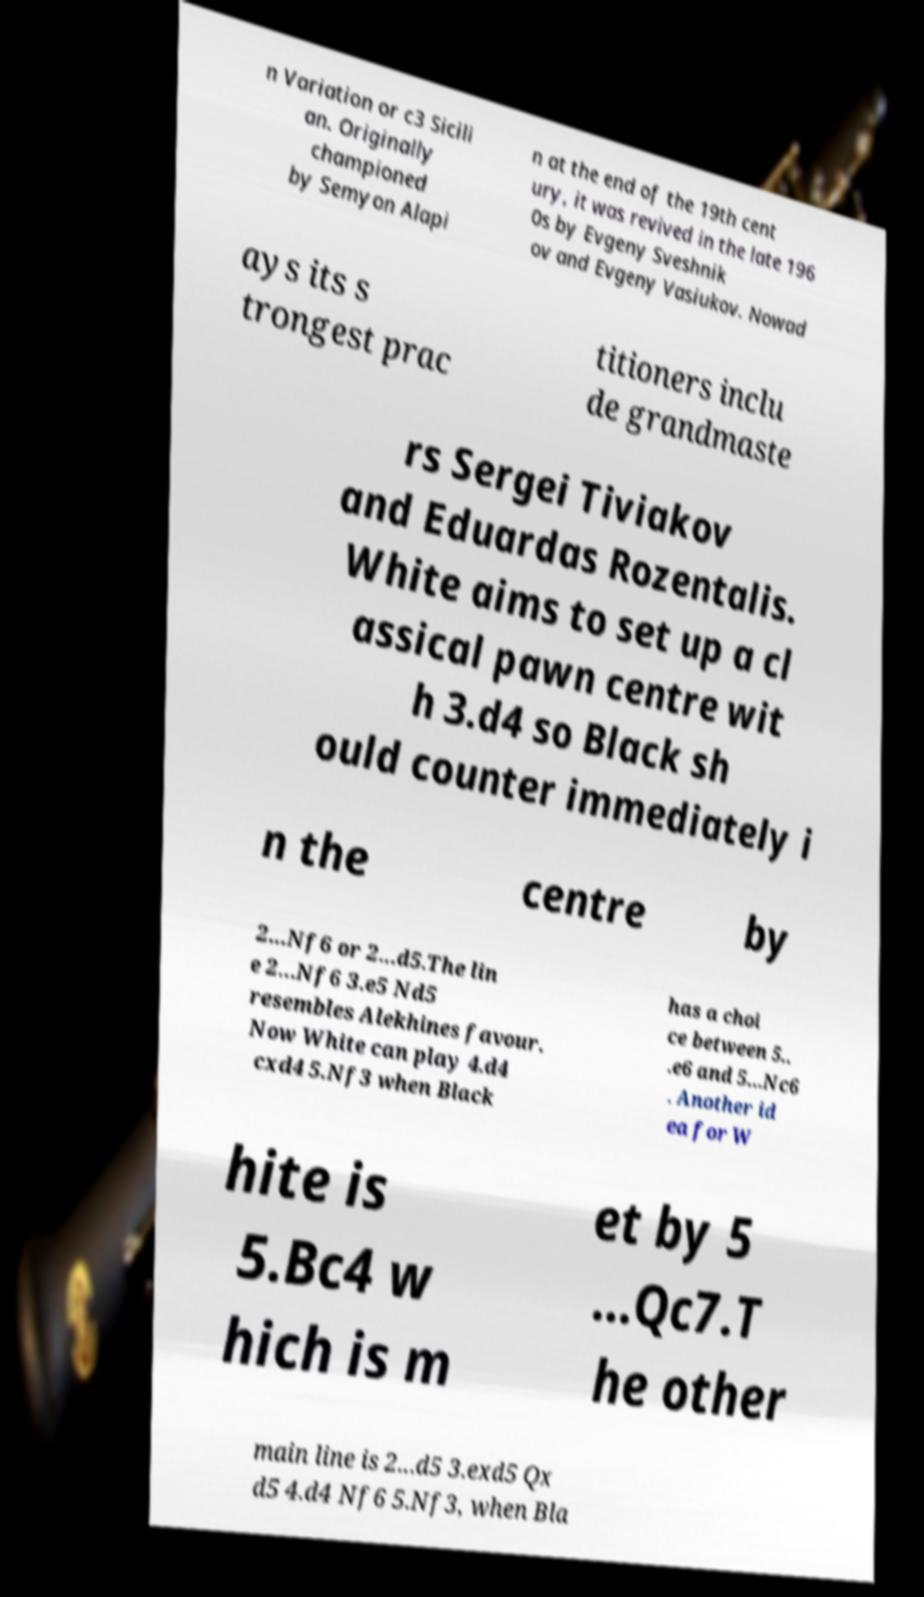What messages or text are displayed in this image? I need them in a readable, typed format. n Variation or c3 Sicili an. Originally championed by Semyon Alapi n at the end of the 19th cent ury, it was revived in the late 196 0s by Evgeny Sveshnik ov and Evgeny Vasiukov. Nowad ays its s trongest prac titioners inclu de grandmaste rs Sergei Tiviakov and Eduardas Rozentalis. White aims to set up a cl assical pawn centre wit h 3.d4 so Black sh ould counter immediately i n the centre by 2...Nf6 or 2...d5.The lin e 2...Nf6 3.e5 Nd5 resembles Alekhines favour. Now White can play 4.d4 cxd4 5.Nf3 when Black has a choi ce between 5.. .e6 and 5...Nc6 . Another id ea for W hite is 5.Bc4 w hich is m et by 5 ...Qc7.T he other main line is 2...d5 3.exd5 Qx d5 4.d4 Nf6 5.Nf3, when Bla 